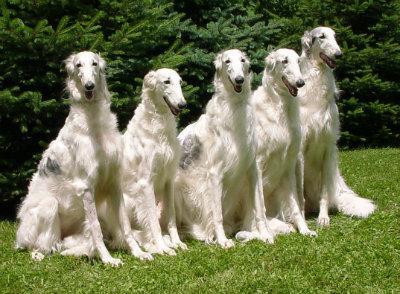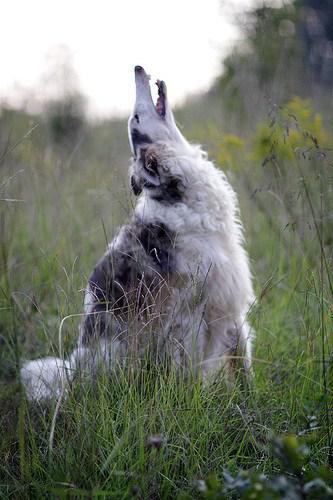The first image is the image on the left, the second image is the image on the right. For the images displayed, is the sentence "Three dogs are standing in the green grass." factually correct? Answer yes or no. No. The first image is the image on the left, the second image is the image on the right. Examine the images to the left and right. Is the description "The hounds in the two images face in the general direction toward each other." accurate? Answer yes or no. No. The first image is the image on the left, the second image is the image on the right. Considering the images on both sides, is "Two dogs are pictured facing each other." valid? Answer yes or no. No. The first image is the image on the left, the second image is the image on the right. Considering the images on both sides, is "An image shows one hound standing in profile with body turned leftward, on green grass in front of a manmade structure." valid? Answer yes or no. No. The first image is the image on the left, the second image is the image on the right. Analyze the images presented: Is the assertion "There are two dogs" valid? Answer yes or no. No. 